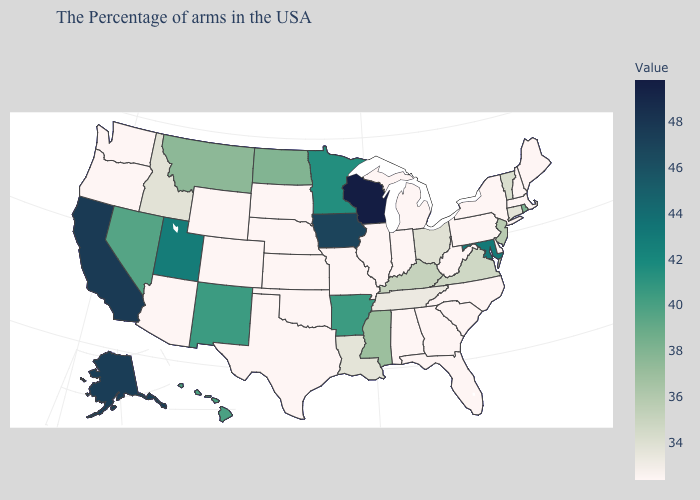Does Alaska have a higher value than Indiana?
Keep it brief. Yes. Which states have the highest value in the USA?
Short answer required. Wisconsin. Among the states that border Vermont , which have the highest value?
Keep it brief. Massachusetts, New Hampshire, New York. Among the states that border Arizona , which have the highest value?
Short answer required. California. Does Michigan have the lowest value in the MidWest?
Answer briefly. Yes. Among the states that border Pennsylvania , which have the highest value?
Be succinct. Maryland. 